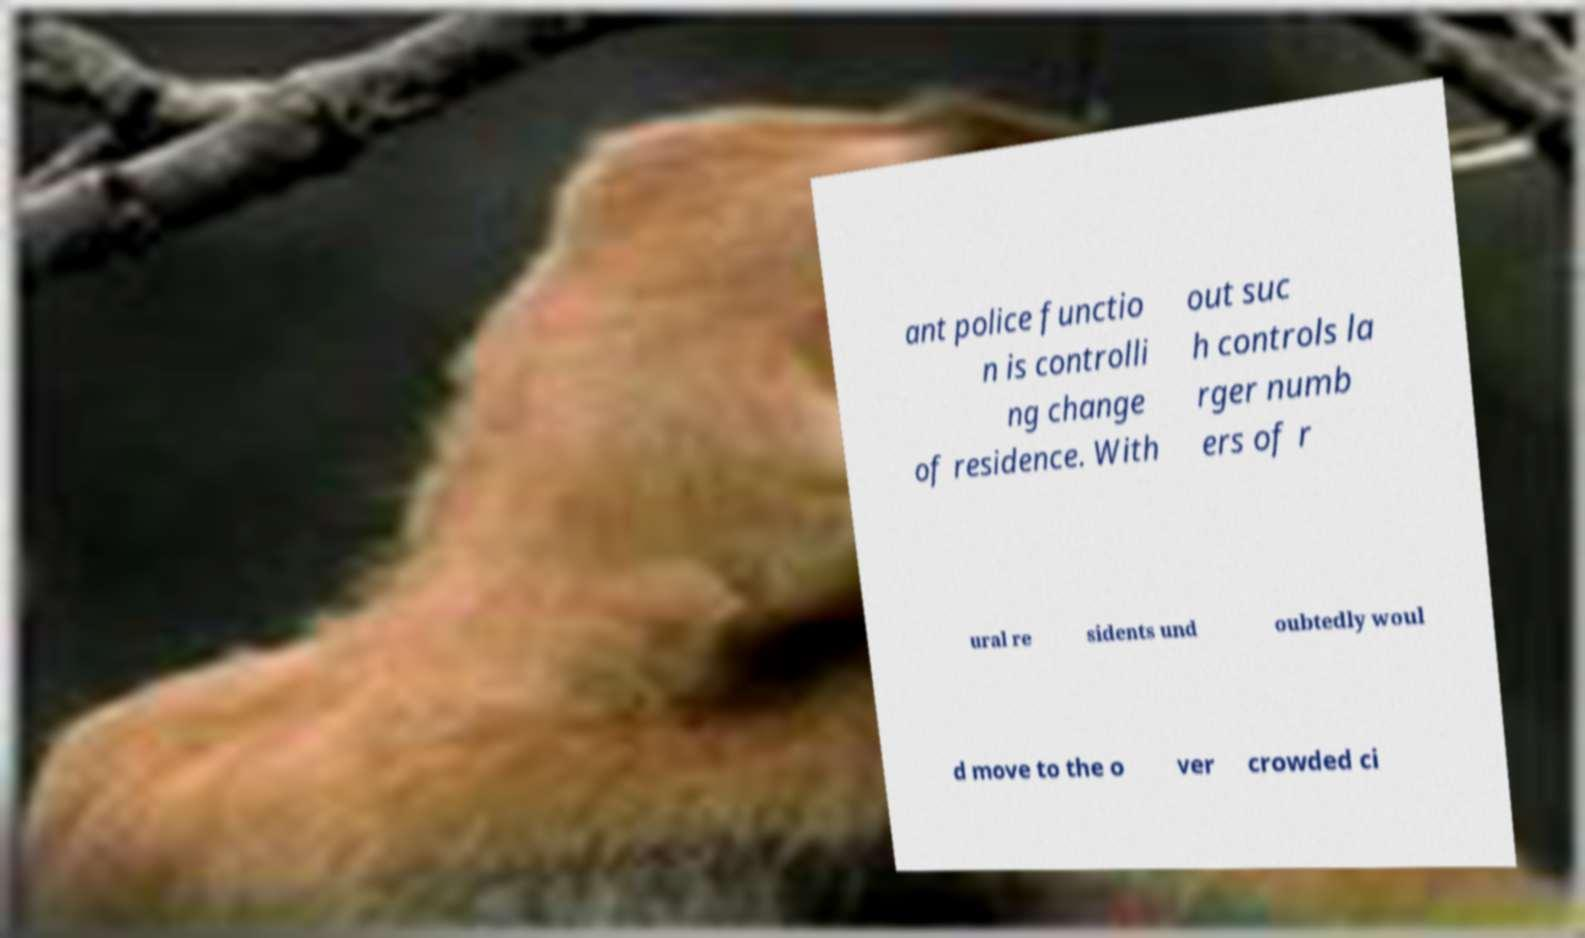What messages or text are displayed in this image? I need them in a readable, typed format. ant police functio n is controlli ng change of residence. With out suc h controls la rger numb ers of r ural re sidents und oubtedly woul d move to the o ver crowded ci 